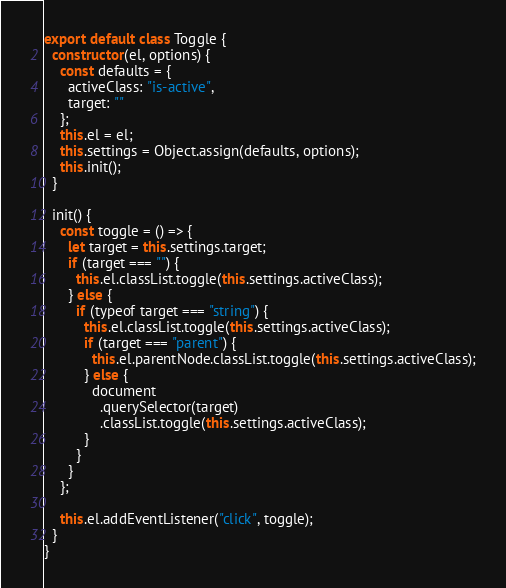Convert code to text. <code><loc_0><loc_0><loc_500><loc_500><_JavaScript_>export default class Toggle {
  constructor(el, options) {
    const defaults = {
      activeClass: "is-active",
      target: ""
    };
    this.el = el;
    this.settings = Object.assign(defaults, options);
    this.init();
  }

  init() {
    const toggle = () => {
      let target = this.settings.target;
      if (target === "") {
        this.el.classList.toggle(this.settings.activeClass);
      } else {
        if (typeof target === "string") {
          this.el.classList.toggle(this.settings.activeClass);
          if (target === "parent") {
            this.el.parentNode.classList.toggle(this.settings.activeClass);
          } else {
            document
              .querySelector(target)
              .classList.toggle(this.settings.activeClass);
          }
        }
      }
    };

    this.el.addEventListener("click", toggle);
  }
}
</code> 